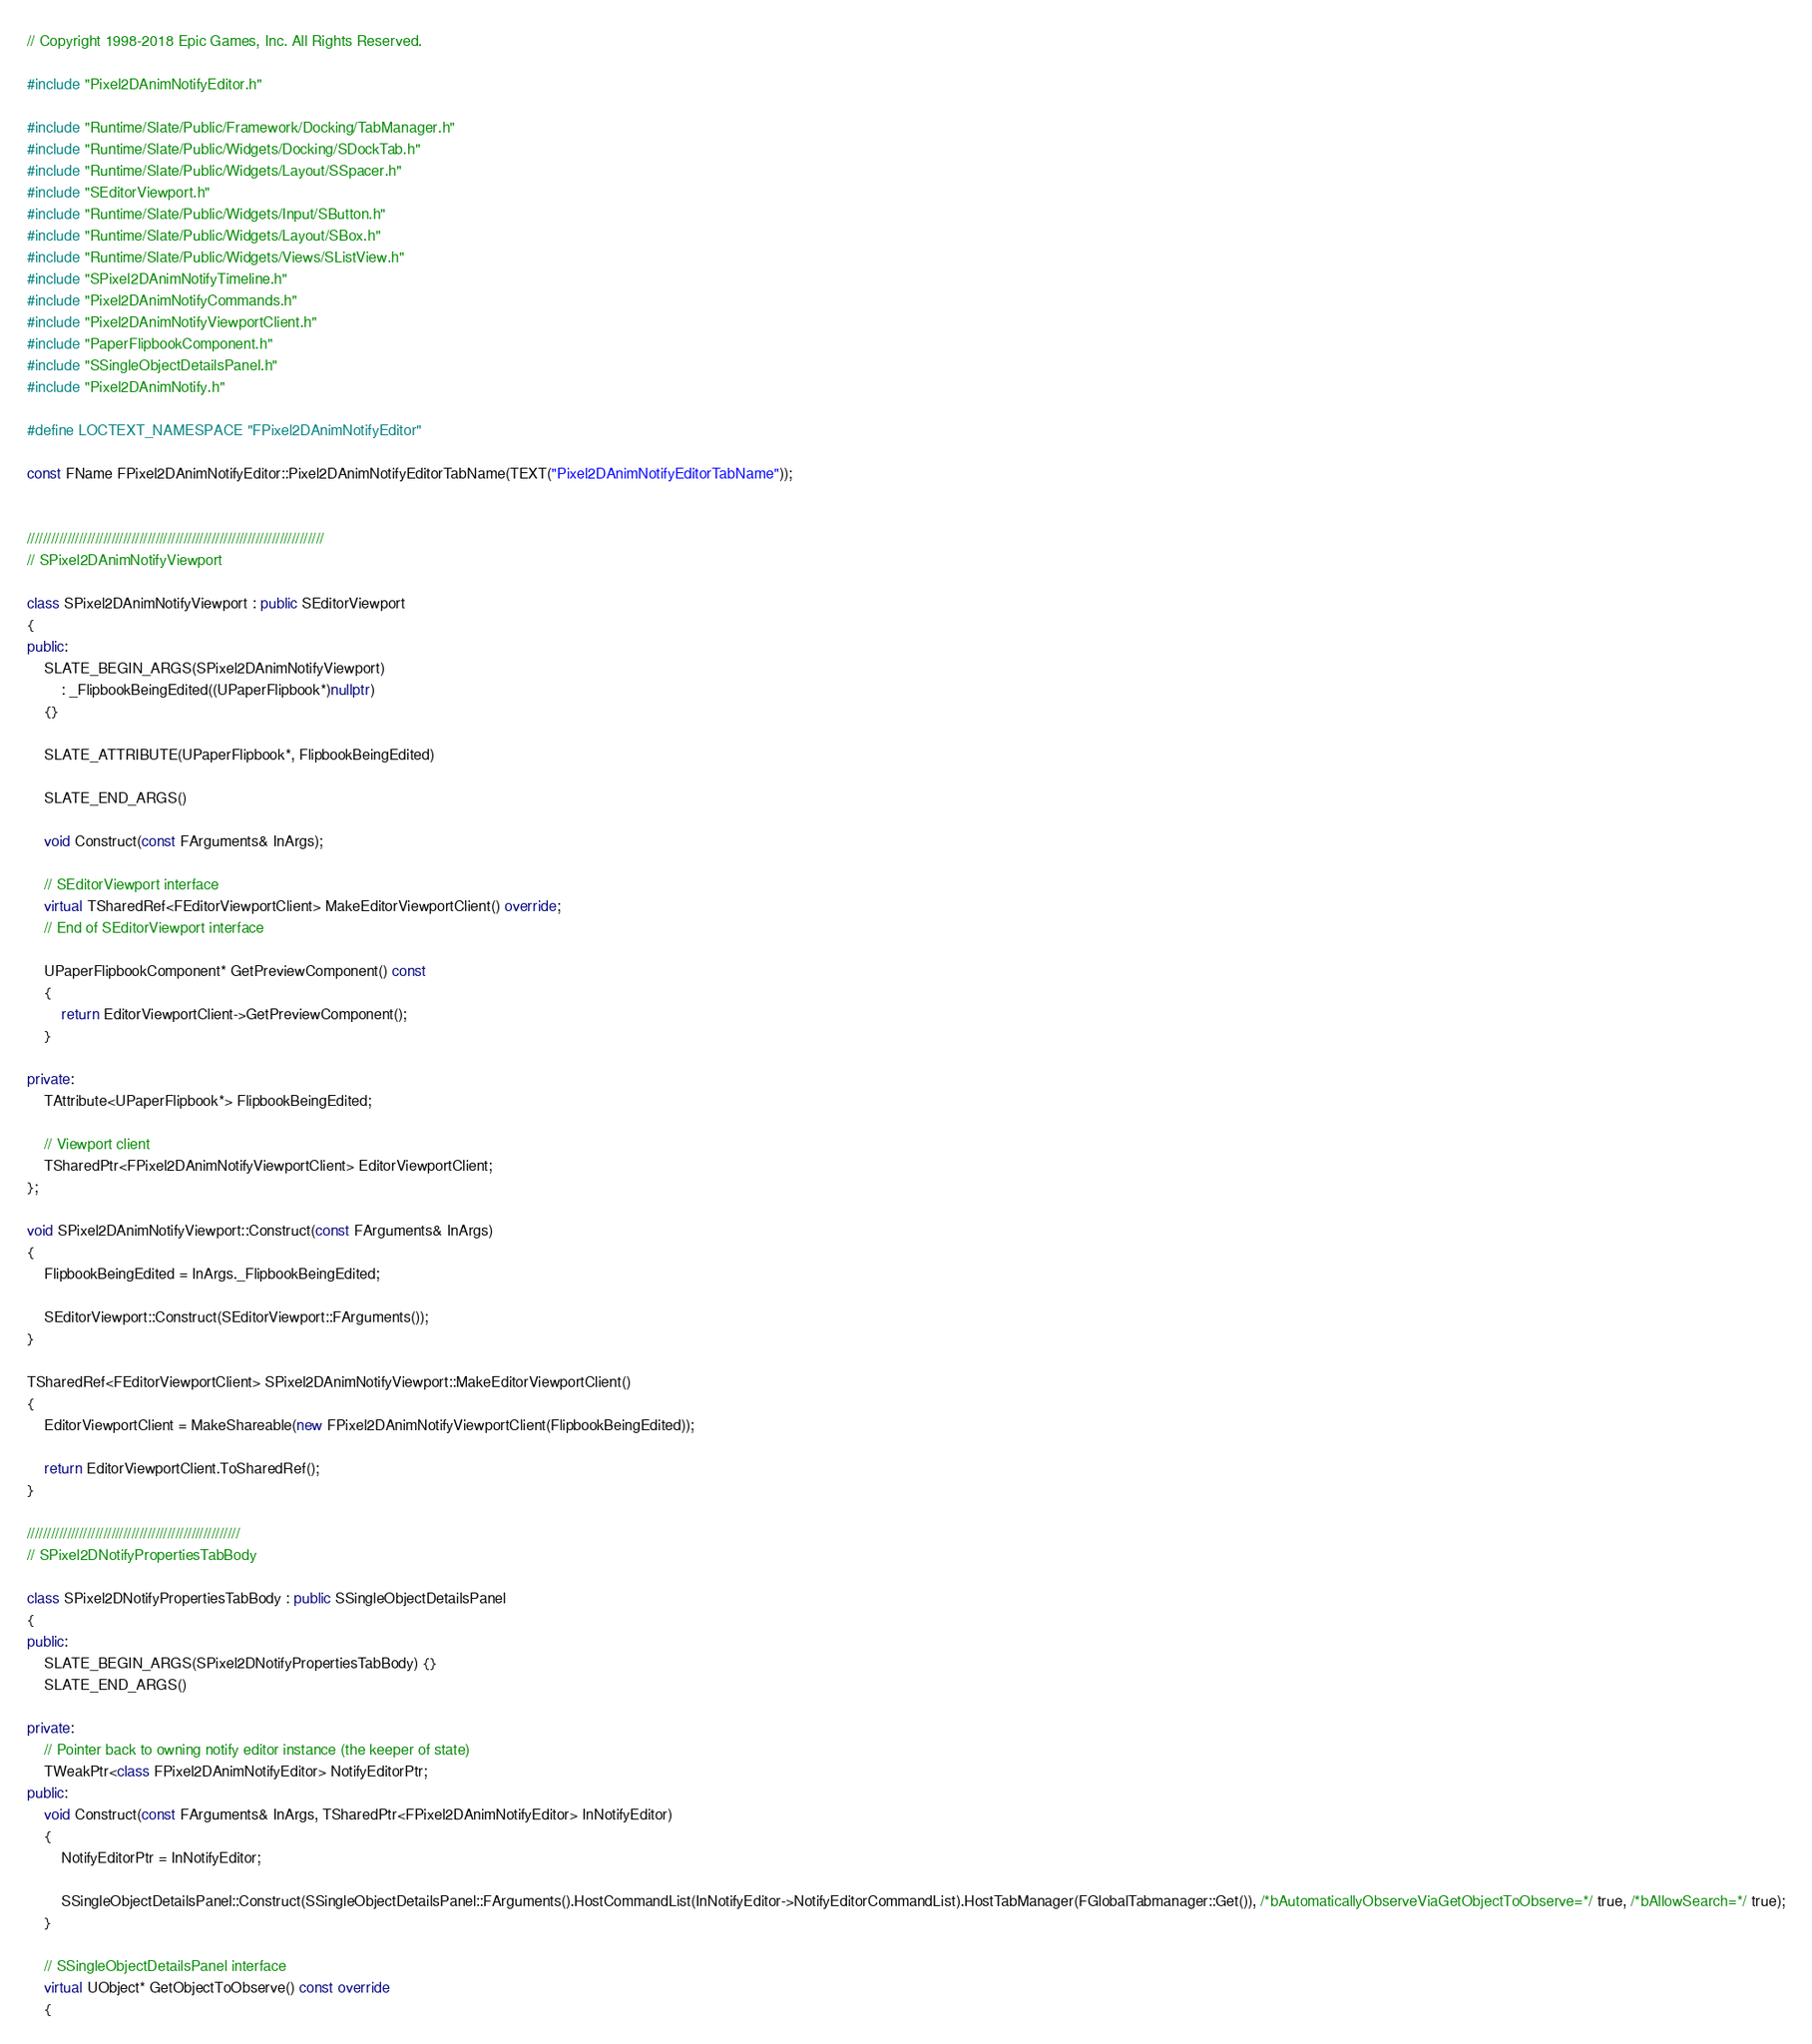<code> <loc_0><loc_0><loc_500><loc_500><_C++_>// Copyright 1998-2018 Epic Games, Inc. All Rights Reserved.

#include "Pixel2DAnimNotifyEditor.h"

#include "Runtime/Slate/Public/Framework/Docking/TabManager.h"
#include "Runtime/Slate/Public/Widgets/Docking/SDockTab.h"
#include "Runtime/Slate/Public/Widgets/Layout/SSpacer.h"
#include "SEditorViewport.h"
#include "Runtime/Slate/Public/Widgets/Input/SButton.h"
#include "Runtime/Slate/Public/Widgets/Layout/SBox.h"
#include "Runtime/Slate/Public/Widgets/Views/SListView.h"
#include "SPixel2DAnimNotifyTimeline.h"
#include "Pixel2DAnimNotifyCommands.h"
#include "Pixel2DAnimNotifyViewportClient.h"
#include "PaperFlipbookComponent.h"
#include "SSingleObjectDetailsPanel.h"
#include "Pixel2DAnimNotify.h"

#define LOCTEXT_NAMESPACE "FPixel2DAnimNotifyEditor"

const FName FPixel2DAnimNotifyEditor::Pixel2DAnimNotifyEditorTabName(TEXT("Pixel2DAnimNotifyEditorTabName"));


//////////////////////////////////////////////////////////////////////////
// SPixel2DAnimNotifyViewport

class SPixel2DAnimNotifyViewport : public SEditorViewport
{
public:
	SLATE_BEGIN_ARGS(SPixel2DAnimNotifyViewport)
		: _FlipbookBeingEdited((UPaperFlipbook*)nullptr)
	{}

	SLATE_ATTRIBUTE(UPaperFlipbook*, FlipbookBeingEdited)

	SLATE_END_ARGS()

	void Construct(const FArguments& InArgs);
    
	// SEditorViewport interface
	virtual TSharedRef<FEditorViewportClient> MakeEditorViewportClient() override;
	// End of SEditorViewport interface

	UPaperFlipbookComponent* GetPreviewComponent() const
	{
		return EditorViewportClient->GetPreviewComponent();
	}

private:
	TAttribute<UPaperFlipbook*> FlipbookBeingEdited;

	// Viewport client
	TSharedPtr<FPixel2DAnimNotifyViewportClient> EditorViewportClient;
};

void SPixel2DAnimNotifyViewport::Construct(const FArguments& InArgs)
{
	FlipbookBeingEdited = InArgs._FlipbookBeingEdited;

	SEditorViewport::Construct(SEditorViewport::FArguments());
}

TSharedRef<FEditorViewportClient> SPixel2DAnimNotifyViewport::MakeEditorViewportClient()
{
	EditorViewportClient = MakeShareable(new FPixel2DAnimNotifyViewportClient(FlipbookBeingEdited));

	return EditorViewportClient.ToSharedRef();
}

/////////////////////////////////////////////////////
// SPixel2DNotifyPropertiesTabBody

class SPixel2DNotifyPropertiesTabBody : public SSingleObjectDetailsPanel
{
public:
	SLATE_BEGIN_ARGS(SPixel2DNotifyPropertiesTabBody) {}
	SLATE_END_ARGS()

private:
	// Pointer back to owning notify editor instance (the keeper of state)
	TWeakPtr<class FPixel2DAnimNotifyEditor> NotifyEditorPtr;
public:
	void Construct(const FArguments& InArgs, TSharedPtr<FPixel2DAnimNotifyEditor> InNotifyEditor)
	{
		NotifyEditorPtr = InNotifyEditor;

		SSingleObjectDetailsPanel::Construct(SSingleObjectDetailsPanel::FArguments().HostCommandList(InNotifyEditor->NotifyEditorCommandList).HostTabManager(FGlobalTabmanager::Get()), /*bAutomaticallyObserveViaGetObjectToObserve=*/ true, /*bAllowSearch=*/ true);
	}

	// SSingleObjectDetailsPanel interface
	virtual UObject* GetObjectToObserve() const override
	{</code> 